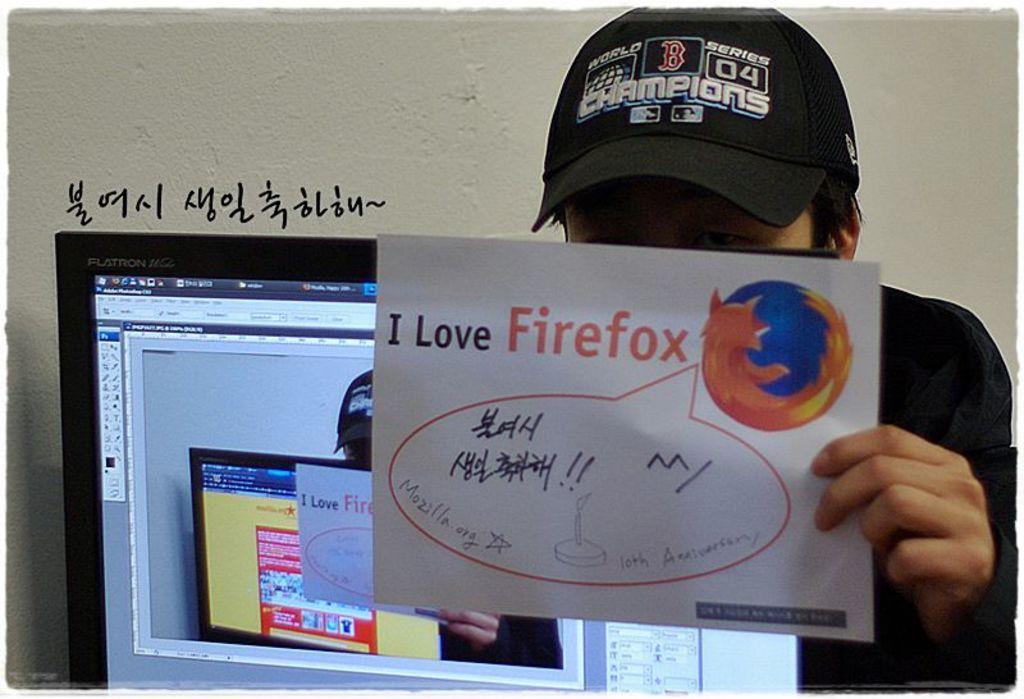In one or two sentences, can you explain what this image depicts? In this image there is a person holding a paper with some text, beside him there is a monitor. In the background there is a wall. On the wall there is some text. 